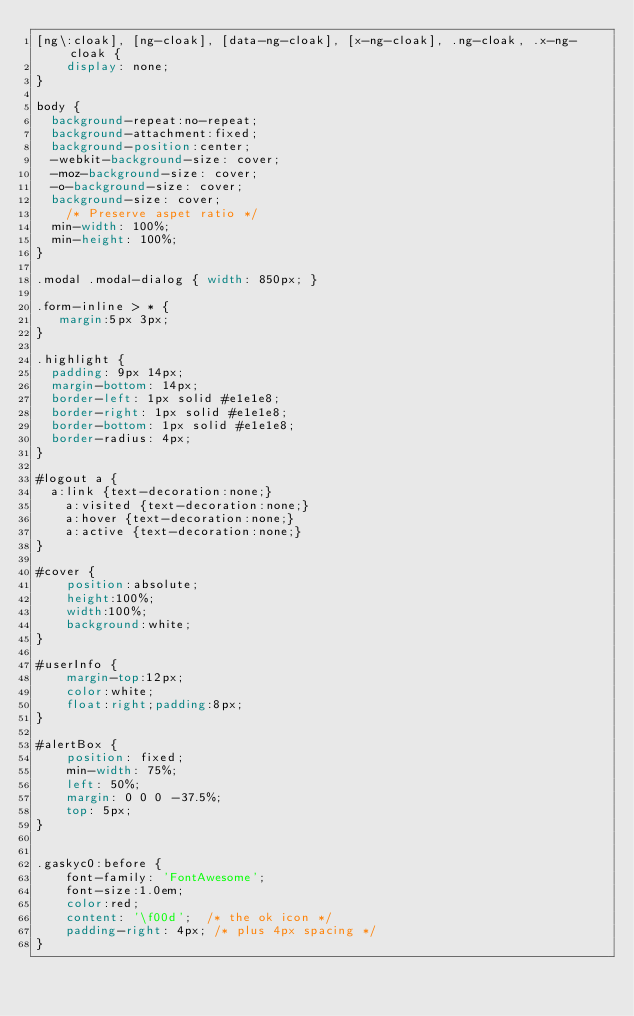<code> <loc_0><loc_0><loc_500><loc_500><_CSS_>[ng\:cloak], [ng-cloak], [data-ng-cloak], [x-ng-cloak], .ng-cloak, .x-ng-cloak {
    display: none;
}

body {
	background-repeat:no-repeat; 
	background-attachment:fixed;
	background-position:center;
	-webkit-background-size: cover;
	-moz-background-size: cover;
	-o-background-size: cover;
	background-size: cover;
	  /* Preserve aspet ratio */
	min-width: 100%;
	min-height: 100%;
}

.modal .modal-dialog { width: 850px; }

.form-inline > * {
   margin:5px 3px;
}

.highlight {
	padding: 9px 14px;
	margin-bottom: 14px;
	border-left: 1px solid #e1e1e8;
	border-right: 1px solid #e1e1e8;
	border-bottom: 1px solid #e1e1e8;
	border-radius: 4px;
}

#logout a {
	a:link {text-decoration:none;}
    a:visited {text-decoration:none;}
    a:hover {text-decoration:none;}
    a:active {text-decoration:none;}
}

#cover {
    position:absolute;
    height:100%;
    width:100%;
    background:white;
}

#userInfo {
    margin-top:12px;
    color:white;
    float:right;padding:8px;
}

#alertBox {
    position: fixed;
    min-width: 75%;
    left: 50%;
    margin: 0 0 0 -37.5%;
    top: 5px;
}


.gaskyc0:before {
    font-family: 'FontAwesome';
    font-size:1.0em;
    color:red;
    content: '\f00d';  /* the ok icon */
    padding-right: 4px; /* plus 4px spacing */
}
</code> 